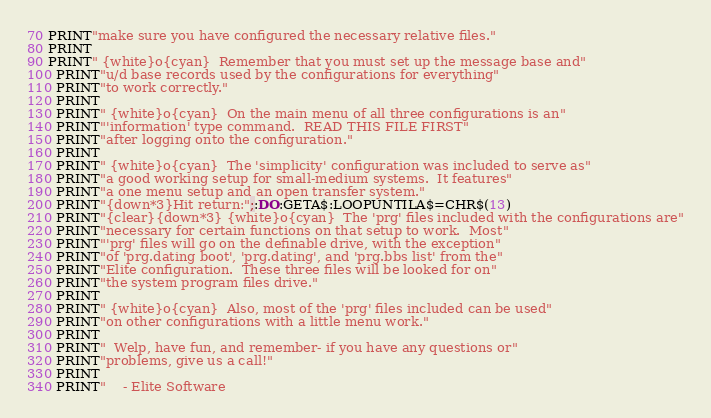<code> <loc_0><loc_0><loc_500><loc_500><_VisualBasic_>70 PRINT"make sure you have configured the necessary relative files."
80 PRINT
90 PRINT" {white}o{cyan}  Remember that you must set up the message base and"
100 PRINT"u/d base records used by the configurations for everything"
110 PRINT"to work correctly."
120 PRINT
130 PRINT" {white}o{cyan}  On the main menu of all three configurations is an"
140 PRINT"'information' type command.  READ THIS FILE FIRST"
150 PRINT"after logging onto the configuration."
160 PRINT
170 PRINT" {white}o{cyan}  The 'simplicity' configuration was included to serve as"
180 PRINT"a good working setup for small-medium systems.  It features"
190 PRINT"a one menu setup and an open transfer system."
200 PRINT"{down*3}Hit return:";:DO:GETA$:LOOPUNTILA$=CHR$(13)
210 PRINT"{clear}{down*3} {white}o{cyan}  The 'prg' files included with the configurations are"
220 PRINT"necessary for certain functions on that setup to work.  Most"
230 PRINT"'prg' files will go on the definable drive, with the exception"
240 PRINT"of 'prg.dating boot', 'prg.dating', and 'prg.bbs list' from the"
250 PRINT"Elite configuration.  These three files will be looked for on"
260 PRINT"the system program files drive."
270 PRINT
280 PRINT" {white}o{cyan}  Also, most of the 'prg' files included can be used"
290 PRINT"on other configurations with a little menu work."
300 PRINT
310 PRINT"  Welp, have fun, and remember- if you have any questions or"
320 PRINT"problems, give us a call!"
330 PRINT
340 PRINT"    - Elite Software
</code> 